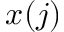<formula> <loc_0><loc_0><loc_500><loc_500>x ( j )</formula> 